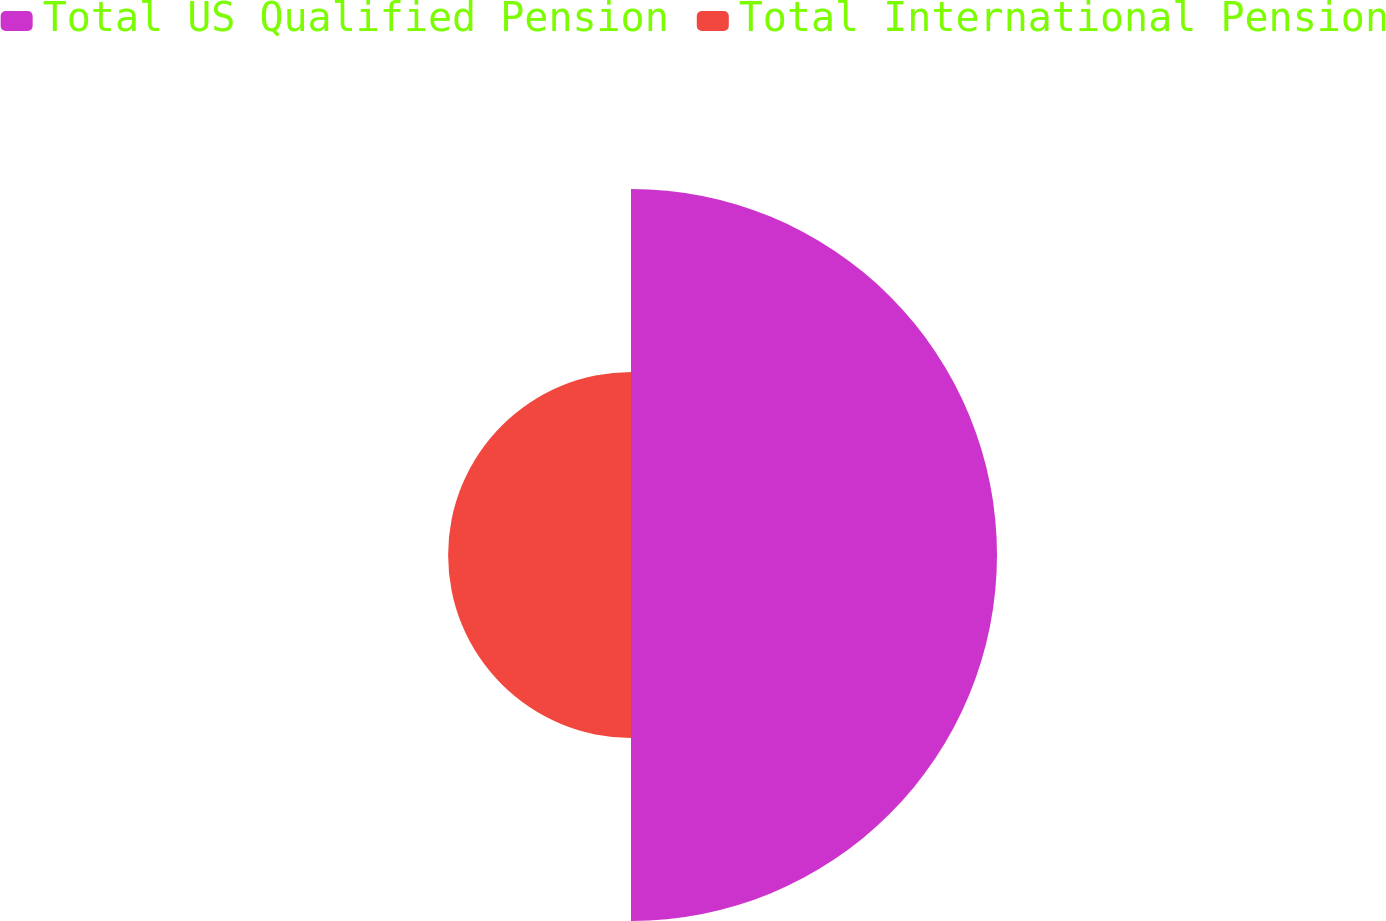Convert chart to OTSL. <chart><loc_0><loc_0><loc_500><loc_500><pie_chart><fcel>Total US Qualified Pension<fcel>Total International Pension<nl><fcel>66.68%<fcel>33.32%<nl></chart> 